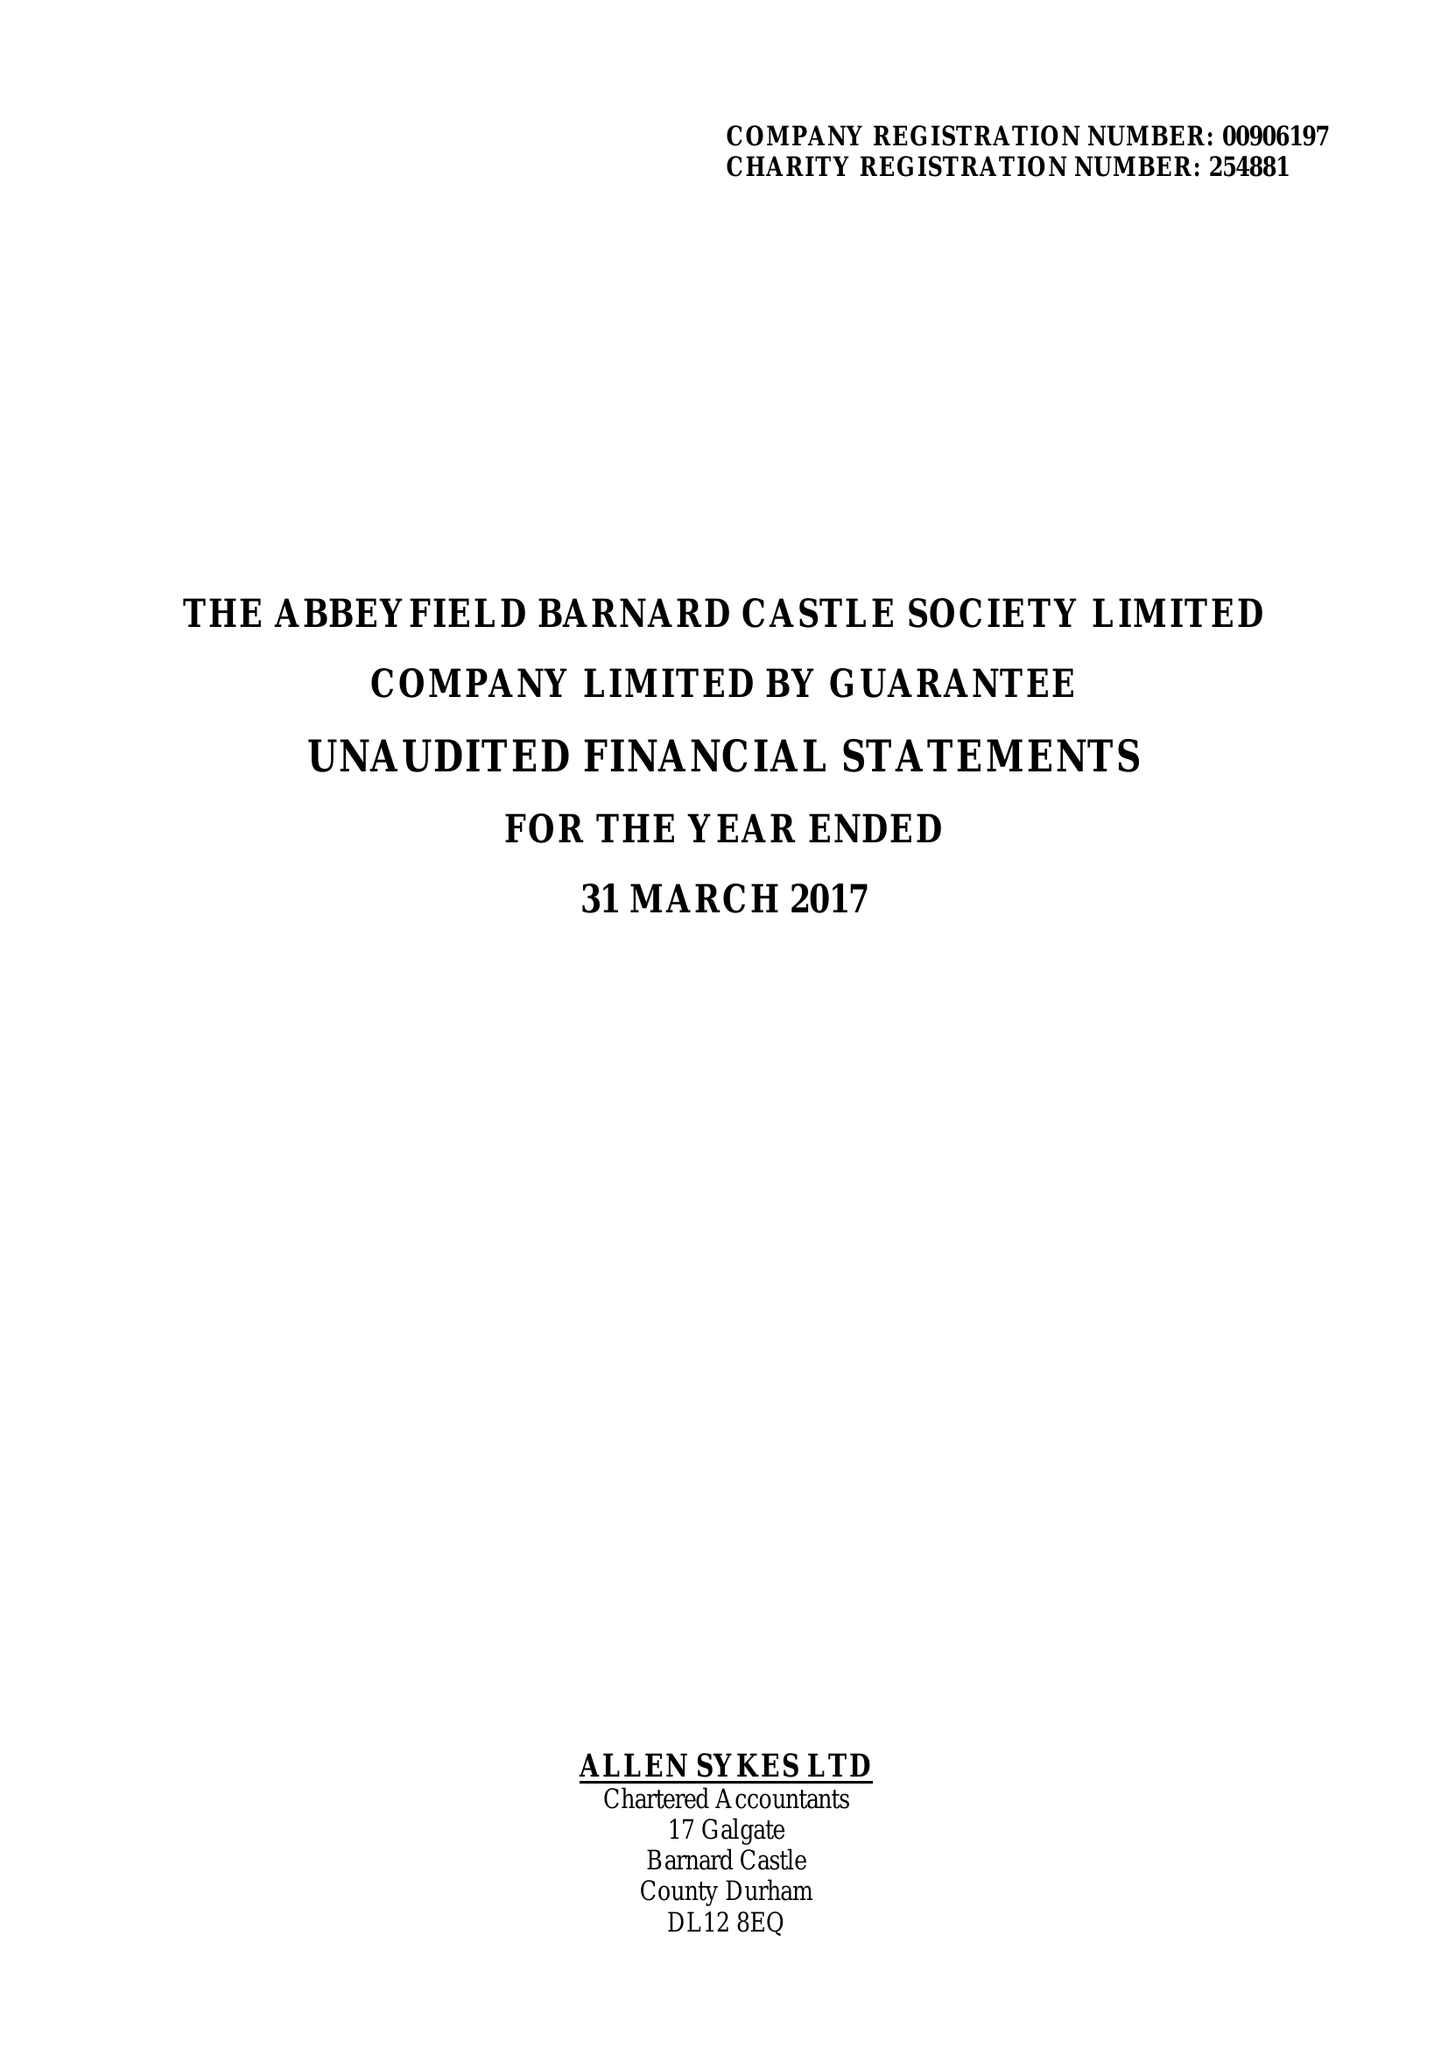What is the value for the report_date?
Answer the question using a single word or phrase. 2017-03-31 